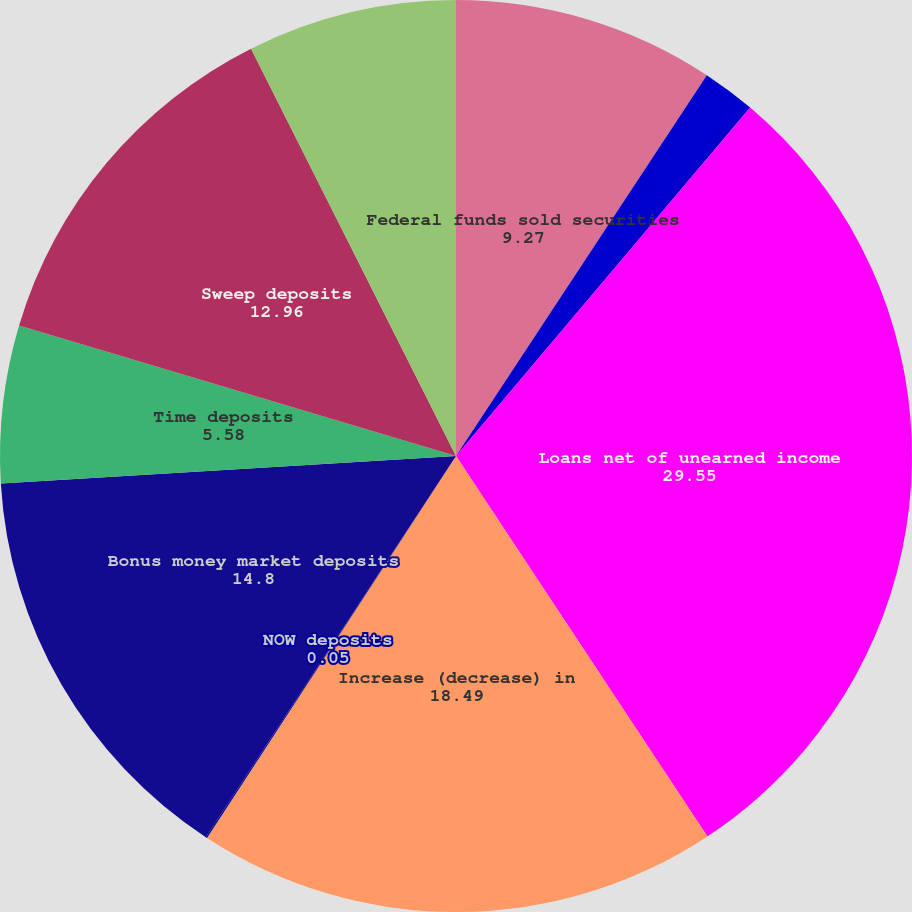<chart> <loc_0><loc_0><loc_500><loc_500><pie_chart><fcel>Federal funds sold securities<fcel>Investment securities<fcel>Loans net of unearned income<fcel>Increase (decrease) in<fcel>NOW deposits<fcel>Bonus money market deposits<fcel>Time deposits<fcel>Sweep deposits<fcel>Total increase (decrease) in<nl><fcel>9.27%<fcel>1.89%<fcel>29.55%<fcel>18.49%<fcel>0.05%<fcel>14.8%<fcel>5.58%<fcel>12.96%<fcel>7.42%<nl></chart> 